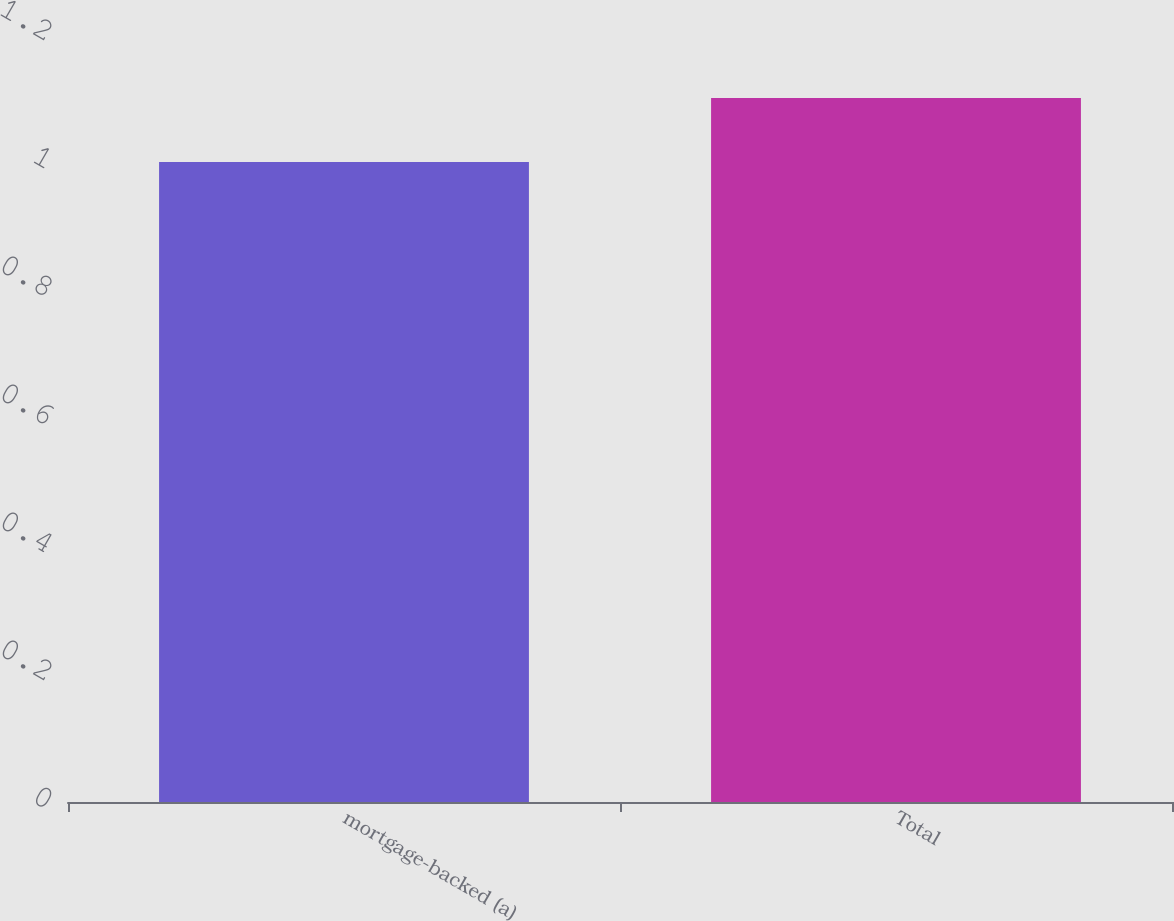Convert chart. <chart><loc_0><loc_0><loc_500><loc_500><bar_chart><fcel>mortgage-backed (a)<fcel>Total<nl><fcel>1<fcel>1.1<nl></chart> 